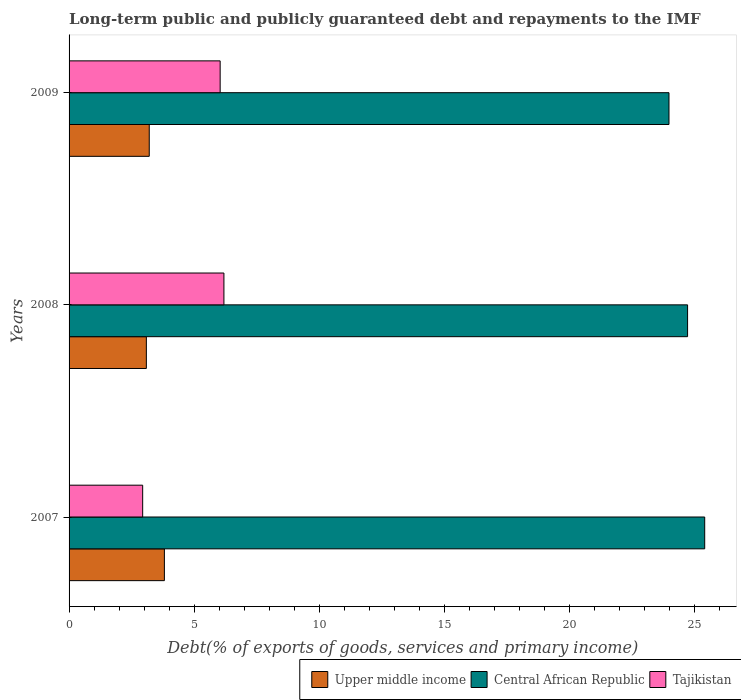How many different coloured bars are there?
Offer a terse response. 3. How many groups of bars are there?
Offer a very short reply. 3. Are the number of bars per tick equal to the number of legend labels?
Offer a very short reply. Yes. How many bars are there on the 3rd tick from the top?
Provide a succinct answer. 3. What is the label of the 2nd group of bars from the top?
Ensure brevity in your answer.  2008. What is the debt and repayments in Central African Republic in 2007?
Keep it short and to the point. 25.42. Across all years, what is the maximum debt and repayments in Central African Republic?
Your answer should be very brief. 25.42. Across all years, what is the minimum debt and repayments in Upper middle income?
Your answer should be very brief. 3.09. In which year was the debt and repayments in Upper middle income minimum?
Ensure brevity in your answer.  2008. What is the total debt and repayments in Upper middle income in the graph?
Make the answer very short. 10.11. What is the difference between the debt and repayments in Upper middle income in 2008 and that in 2009?
Offer a terse response. -0.12. What is the difference between the debt and repayments in Upper middle income in 2009 and the debt and repayments in Central African Republic in 2008?
Offer a terse response. -21.53. What is the average debt and repayments in Upper middle income per year?
Your answer should be very brief. 3.37. In the year 2008, what is the difference between the debt and repayments in Tajikistan and debt and repayments in Central African Republic?
Give a very brief answer. -18.54. In how many years, is the debt and repayments in Tajikistan greater than 21 %?
Provide a short and direct response. 0. What is the ratio of the debt and repayments in Tajikistan in 2007 to that in 2008?
Make the answer very short. 0.48. Is the difference between the debt and repayments in Tajikistan in 2007 and 2008 greater than the difference between the debt and repayments in Central African Republic in 2007 and 2008?
Provide a short and direct response. No. What is the difference between the highest and the second highest debt and repayments in Upper middle income?
Offer a very short reply. 0.61. What is the difference between the highest and the lowest debt and repayments in Central African Republic?
Your answer should be compact. 1.43. What does the 3rd bar from the top in 2007 represents?
Your answer should be compact. Upper middle income. What does the 3rd bar from the bottom in 2008 represents?
Ensure brevity in your answer.  Tajikistan. How many bars are there?
Your response must be concise. 9. Are all the bars in the graph horizontal?
Keep it short and to the point. Yes. How many years are there in the graph?
Your answer should be very brief. 3. How many legend labels are there?
Provide a short and direct response. 3. What is the title of the graph?
Your response must be concise. Long-term public and publicly guaranteed debt and repayments to the IMF. What is the label or title of the X-axis?
Provide a short and direct response. Debt(% of exports of goods, services and primary income). What is the Debt(% of exports of goods, services and primary income) in Upper middle income in 2007?
Provide a succinct answer. 3.81. What is the Debt(% of exports of goods, services and primary income) of Central African Republic in 2007?
Your answer should be compact. 25.42. What is the Debt(% of exports of goods, services and primary income) in Tajikistan in 2007?
Your response must be concise. 2.94. What is the Debt(% of exports of goods, services and primary income) in Upper middle income in 2008?
Your answer should be compact. 3.09. What is the Debt(% of exports of goods, services and primary income) in Central African Republic in 2008?
Provide a succinct answer. 24.74. What is the Debt(% of exports of goods, services and primary income) in Tajikistan in 2008?
Your answer should be compact. 6.19. What is the Debt(% of exports of goods, services and primary income) of Upper middle income in 2009?
Your answer should be compact. 3.21. What is the Debt(% of exports of goods, services and primary income) of Central African Republic in 2009?
Keep it short and to the point. 23.99. What is the Debt(% of exports of goods, services and primary income) of Tajikistan in 2009?
Offer a very short reply. 6.04. Across all years, what is the maximum Debt(% of exports of goods, services and primary income) in Upper middle income?
Offer a very short reply. 3.81. Across all years, what is the maximum Debt(% of exports of goods, services and primary income) in Central African Republic?
Your response must be concise. 25.42. Across all years, what is the maximum Debt(% of exports of goods, services and primary income) in Tajikistan?
Ensure brevity in your answer.  6.19. Across all years, what is the minimum Debt(% of exports of goods, services and primary income) of Upper middle income?
Keep it short and to the point. 3.09. Across all years, what is the minimum Debt(% of exports of goods, services and primary income) in Central African Republic?
Your answer should be compact. 23.99. Across all years, what is the minimum Debt(% of exports of goods, services and primary income) of Tajikistan?
Your answer should be compact. 2.94. What is the total Debt(% of exports of goods, services and primary income) of Upper middle income in the graph?
Keep it short and to the point. 10.11. What is the total Debt(% of exports of goods, services and primary income) in Central African Republic in the graph?
Your answer should be very brief. 74.15. What is the total Debt(% of exports of goods, services and primary income) of Tajikistan in the graph?
Your answer should be very brief. 15.18. What is the difference between the Debt(% of exports of goods, services and primary income) of Upper middle income in 2007 and that in 2008?
Offer a very short reply. 0.72. What is the difference between the Debt(% of exports of goods, services and primary income) in Central African Republic in 2007 and that in 2008?
Provide a short and direct response. 0.69. What is the difference between the Debt(% of exports of goods, services and primary income) in Tajikistan in 2007 and that in 2008?
Your answer should be compact. -3.25. What is the difference between the Debt(% of exports of goods, services and primary income) in Upper middle income in 2007 and that in 2009?
Your answer should be very brief. 0.61. What is the difference between the Debt(% of exports of goods, services and primary income) in Central African Republic in 2007 and that in 2009?
Your response must be concise. 1.43. What is the difference between the Debt(% of exports of goods, services and primary income) of Tajikistan in 2007 and that in 2009?
Your response must be concise. -3.1. What is the difference between the Debt(% of exports of goods, services and primary income) in Upper middle income in 2008 and that in 2009?
Provide a succinct answer. -0.12. What is the difference between the Debt(% of exports of goods, services and primary income) in Central African Republic in 2008 and that in 2009?
Make the answer very short. 0.74. What is the difference between the Debt(% of exports of goods, services and primary income) of Tajikistan in 2008 and that in 2009?
Your answer should be very brief. 0.15. What is the difference between the Debt(% of exports of goods, services and primary income) in Upper middle income in 2007 and the Debt(% of exports of goods, services and primary income) in Central African Republic in 2008?
Keep it short and to the point. -20.92. What is the difference between the Debt(% of exports of goods, services and primary income) in Upper middle income in 2007 and the Debt(% of exports of goods, services and primary income) in Tajikistan in 2008?
Ensure brevity in your answer.  -2.38. What is the difference between the Debt(% of exports of goods, services and primary income) in Central African Republic in 2007 and the Debt(% of exports of goods, services and primary income) in Tajikistan in 2008?
Your answer should be very brief. 19.23. What is the difference between the Debt(% of exports of goods, services and primary income) of Upper middle income in 2007 and the Debt(% of exports of goods, services and primary income) of Central African Republic in 2009?
Provide a short and direct response. -20.18. What is the difference between the Debt(% of exports of goods, services and primary income) in Upper middle income in 2007 and the Debt(% of exports of goods, services and primary income) in Tajikistan in 2009?
Offer a terse response. -2.23. What is the difference between the Debt(% of exports of goods, services and primary income) of Central African Republic in 2007 and the Debt(% of exports of goods, services and primary income) of Tajikistan in 2009?
Offer a very short reply. 19.38. What is the difference between the Debt(% of exports of goods, services and primary income) of Upper middle income in 2008 and the Debt(% of exports of goods, services and primary income) of Central African Republic in 2009?
Your response must be concise. -20.9. What is the difference between the Debt(% of exports of goods, services and primary income) in Upper middle income in 2008 and the Debt(% of exports of goods, services and primary income) in Tajikistan in 2009?
Offer a very short reply. -2.95. What is the difference between the Debt(% of exports of goods, services and primary income) in Central African Republic in 2008 and the Debt(% of exports of goods, services and primary income) in Tajikistan in 2009?
Provide a succinct answer. 18.69. What is the average Debt(% of exports of goods, services and primary income) in Upper middle income per year?
Your response must be concise. 3.37. What is the average Debt(% of exports of goods, services and primary income) of Central African Republic per year?
Offer a terse response. 24.72. What is the average Debt(% of exports of goods, services and primary income) of Tajikistan per year?
Make the answer very short. 5.06. In the year 2007, what is the difference between the Debt(% of exports of goods, services and primary income) in Upper middle income and Debt(% of exports of goods, services and primary income) in Central African Republic?
Your answer should be very brief. -21.61. In the year 2007, what is the difference between the Debt(% of exports of goods, services and primary income) of Upper middle income and Debt(% of exports of goods, services and primary income) of Tajikistan?
Offer a very short reply. 0.87. In the year 2007, what is the difference between the Debt(% of exports of goods, services and primary income) of Central African Republic and Debt(% of exports of goods, services and primary income) of Tajikistan?
Your answer should be compact. 22.48. In the year 2008, what is the difference between the Debt(% of exports of goods, services and primary income) in Upper middle income and Debt(% of exports of goods, services and primary income) in Central African Republic?
Make the answer very short. -21.65. In the year 2008, what is the difference between the Debt(% of exports of goods, services and primary income) in Upper middle income and Debt(% of exports of goods, services and primary income) in Tajikistan?
Provide a succinct answer. -3.1. In the year 2008, what is the difference between the Debt(% of exports of goods, services and primary income) in Central African Republic and Debt(% of exports of goods, services and primary income) in Tajikistan?
Give a very brief answer. 18.54. In the year 2009, what is the difference between the Debt(% of exports of goods, services and primary income) in Upper middle income and Debt(% of exports of goods, services and primary income) in Central African Republic?
Keep it short and to the point. -20.79. In the year 2009, what is the difference between the Debt(% of exports of goods, services and primary income) of Upper middle income and Debt(% of exports of goods, services and primary income) of Tajikistan?
Keep it short and to the point. -2.84. In the year 2009, what is the difference between the Debt(% of exports of goods, services and primary income) in Central African Republic and Debt(% of exports of goods, services and primary income) in Tajikistan?
Provide a succinct answer. 17.95. What is the ratio of the Debt(% of exports of goods, services and primary income) of Upper middle income in 2007 to that in 2008?
Your response must be concise. 1.23. What is the ratio of the Debt(% of exports of goods, services and primary income) of Central African Republic in 2007 to that in 2008?
Offer a very short reply. 1.03. What is the ratio of the Debt(% of exports of goods, services and primary income) of Tajikistan in 2007 to that in 2008?
Provide a short and direct response. 0.48. What is the ratio of the Debt(% of exports of goods, services and primary income) of Upper middle income in 2007 to that in 2009?
Ensure brevity in your answer.  1.19. What is the ratio of the Debt(% of exports of goods, services and primary income) of Central African Republic in 2007 to that in 2009?
Offer a terse response. 1.06. What is the ratio of the Debt(% of exports of goods, services and primary income) of Tajikistan in 2007 to that in 2009?
Make the answer very short. 0.49. What is the ratio of the Debt(% of exports of goods, services and primary income) of Upper middle income in 2008 to that in 2009?
Provide a short and direct response. 0.96. What is the ratio of the Debt(% of exports of goods, services and primary income) in Central African Republic in 2008 to that in 2009?
Provide a succinct answer. 1.03. What is the ratio of the Debt(% of exports of goods, services and primary income) in Tajikistan in 2008 to that in 2009?
Your response must be concise. 1.02. What is the difference between the highest and the second highest Debt(% of exports of goods, services and primary income) of Upper middle income?
Offer a terse response. 0.61. What is the difference between the highest and the second highest Debt(% of exports of goods, services and primary income) in Central African Republic?
Your response must be concise. 0.69. What is the difference between the highest and the second highest Debt(% of exports of goods, services and primary income) in Tajikistan?
Offer a very short reply. 0.15. What is the difference between the highest and the lowest Debt(% of exports of goods, services and primary income) in Upper middle income?
Make the answer very short. 0.72. What is the difference between the highest and the lowest Debt(% of exports of goods, services and primary income) of Central African Republic?
Offer a very short reply. 1.43. 